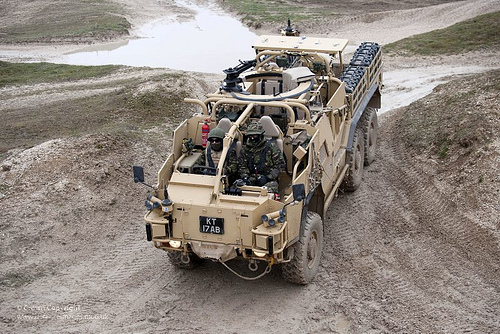<image>
Is the fire extinguisher in the truck? Yes. The fire extinguisher is contained within or inside the truck, showing a containment relationship. 